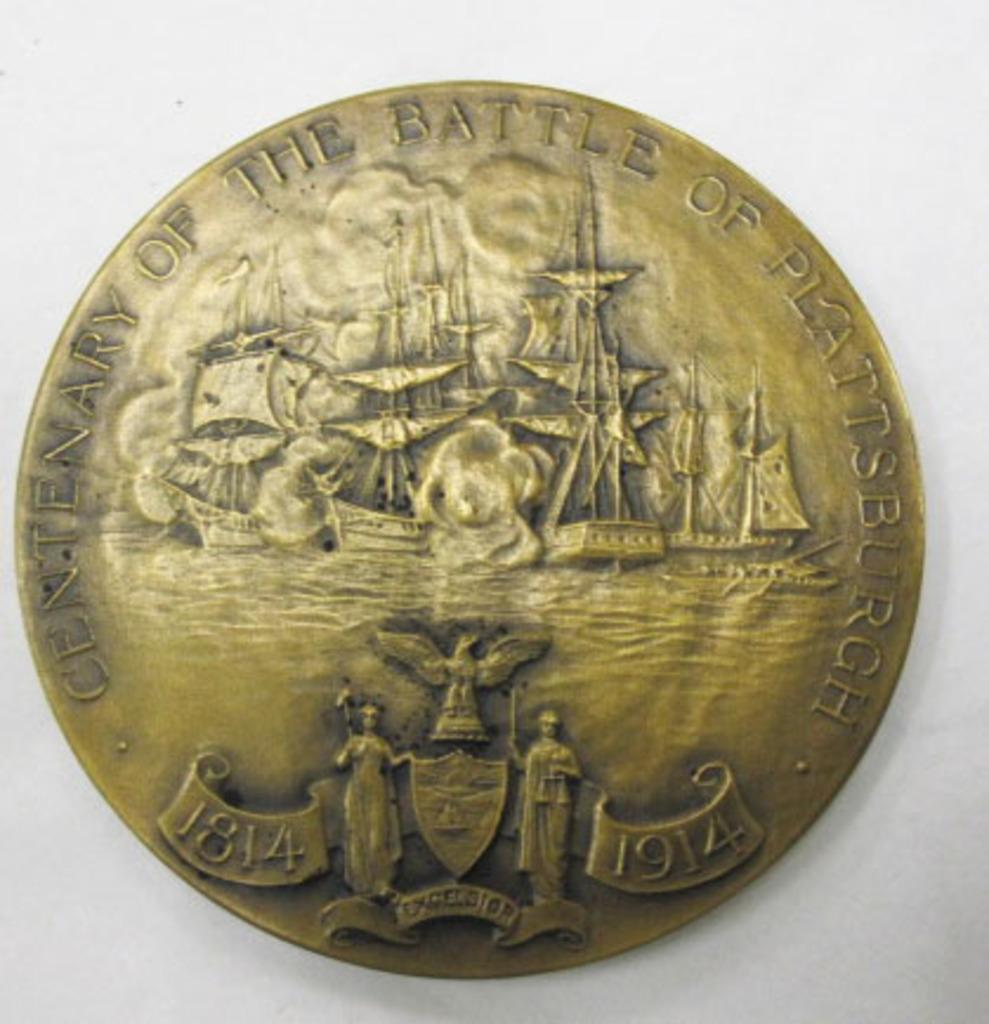<image>
Present a compact description of the photo's key features. A bronze coloured coin depicts The Battle Of Plattsburgh. 